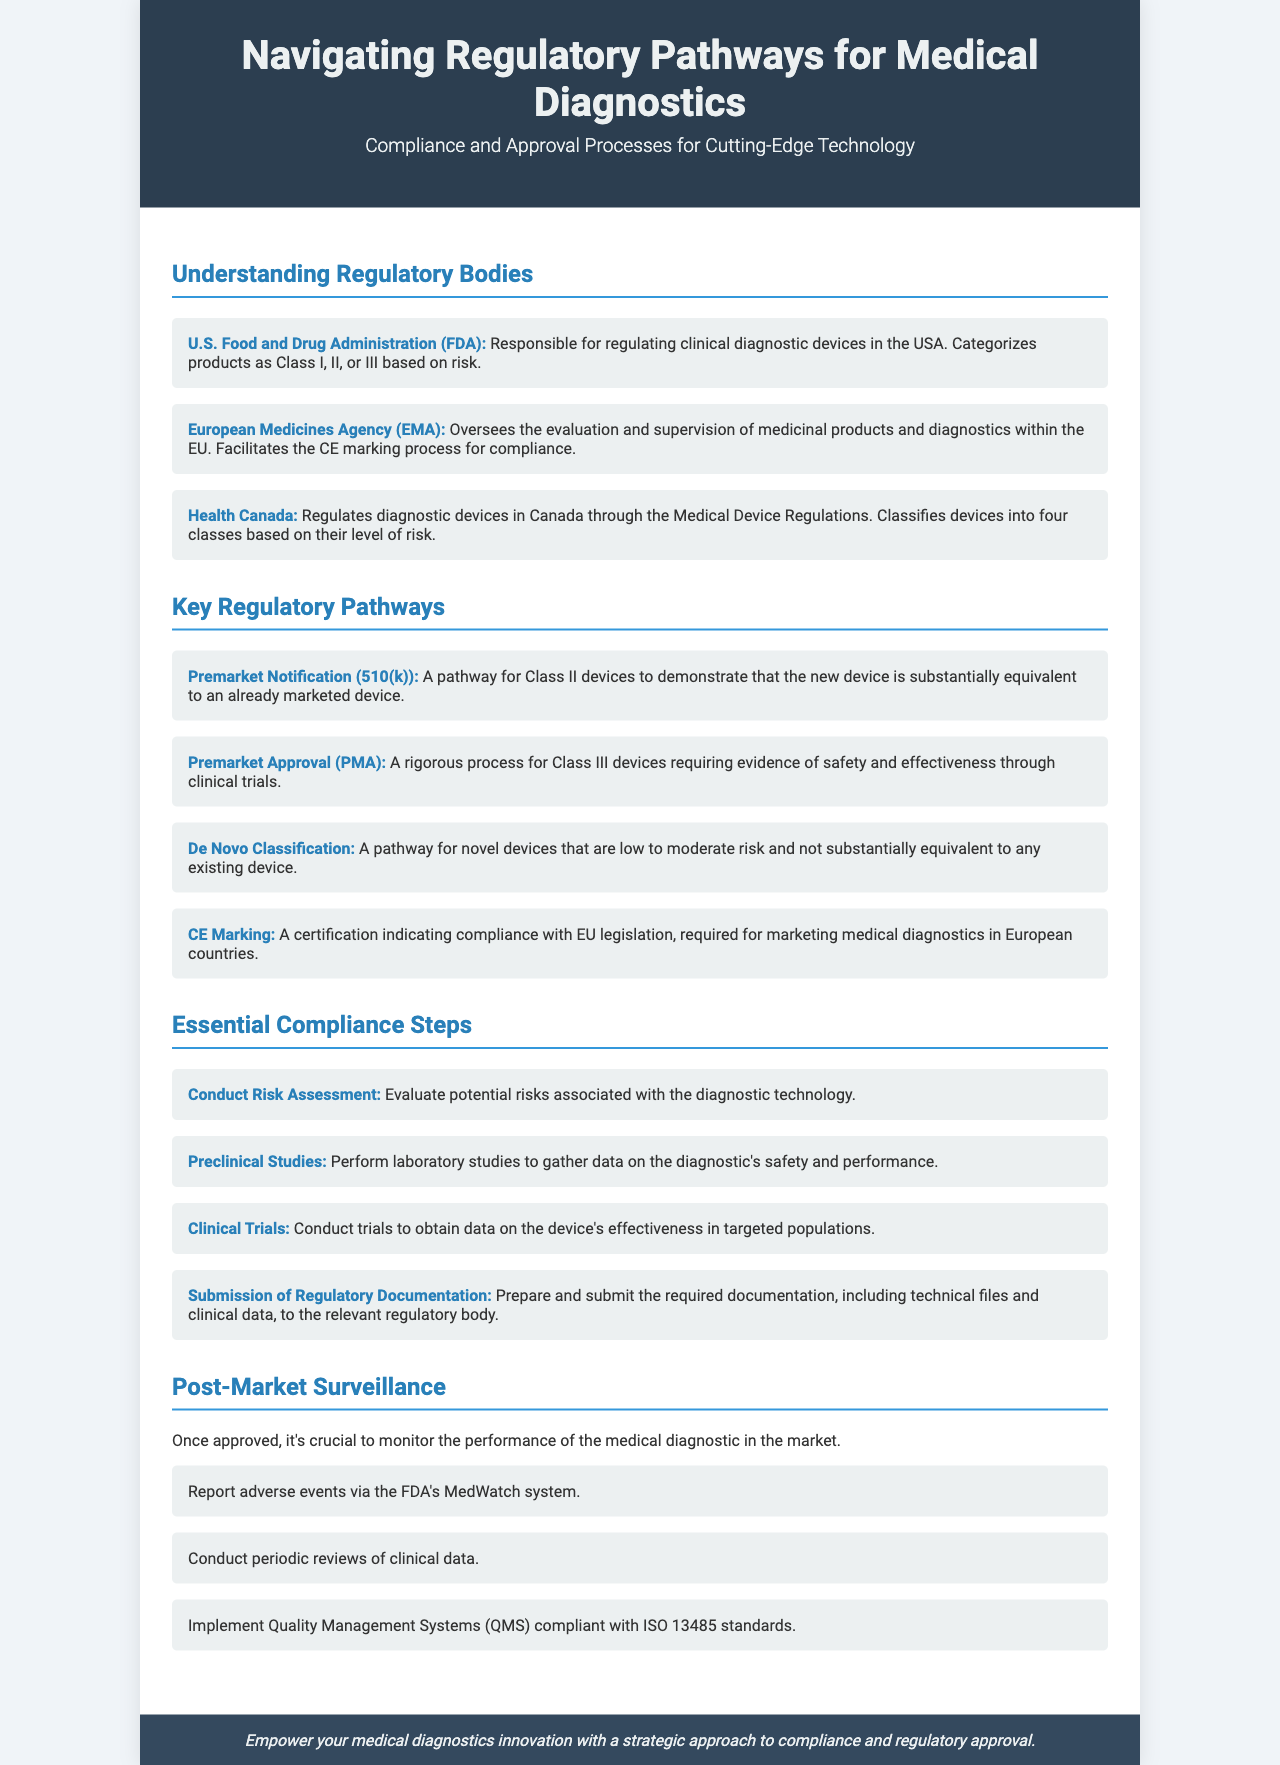What is the main regulatory body in the USA? The main regulatory body responsible for regulating clinical diagnostic devices in the USA is the U.S. Food and Drug Administration (FDA).
Answer: FDA What classification do Class II devices require? Class II devices require a Premarket Notification (510(k)) to demonstrate substantial equivalence to already marketed devices.
Answer: 510(k) What is the primary focus of the post-market surveillance section? The primary focus is on monitoring the performance of the medical diagnostic in the market after approval.
Answer: Monitoring What type of clinical trials are needed for Class III devices? Class III devices require evidence of safety and effectiveness through clinical trials, as described in the Premarket Approval (PMA) pathway.
Answer: Clinical trials Which European agency facilitates the CE marking process? The European Medicines Agency (EMA) oversees the evaluation and supervision of medicinal products and diagnostics within the EU to facilitate CE marking.
Answer: EMA What standard must Quality Management Systems (QMS) comply with? Quality Management Systems (QMS) must comply with ISO 13485 standards.
Answer: ISO 13485 What is the first step in essential compliance steps? The first step is to conduct a Risk Assessment to evaluate potential risks associated with the diagnostic technology.
Answer: Risk Assessment Which classification pathway is for novel devices that are low to moderate risk? The De Novo Classification pathway is reserved for novel devices that are low to moderate risk and not substantially equivalent to any existing device.
Answer: De Novo Classification 